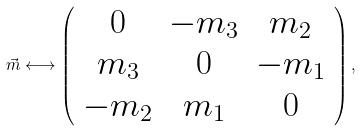<formula> <loc_0><loc_0><loc_500><loc_500>\vec { m } \longleftrightarrow \left ( \begin{array} { c c c } 0 & - m _ { 3 } & m _ { 2 } \\ m _ { 3 } & 0 & - m _ { 1 } \\ - m _ { 2 } & m _ { 1 } & 0 \end{array} \right ) ,</formula> 